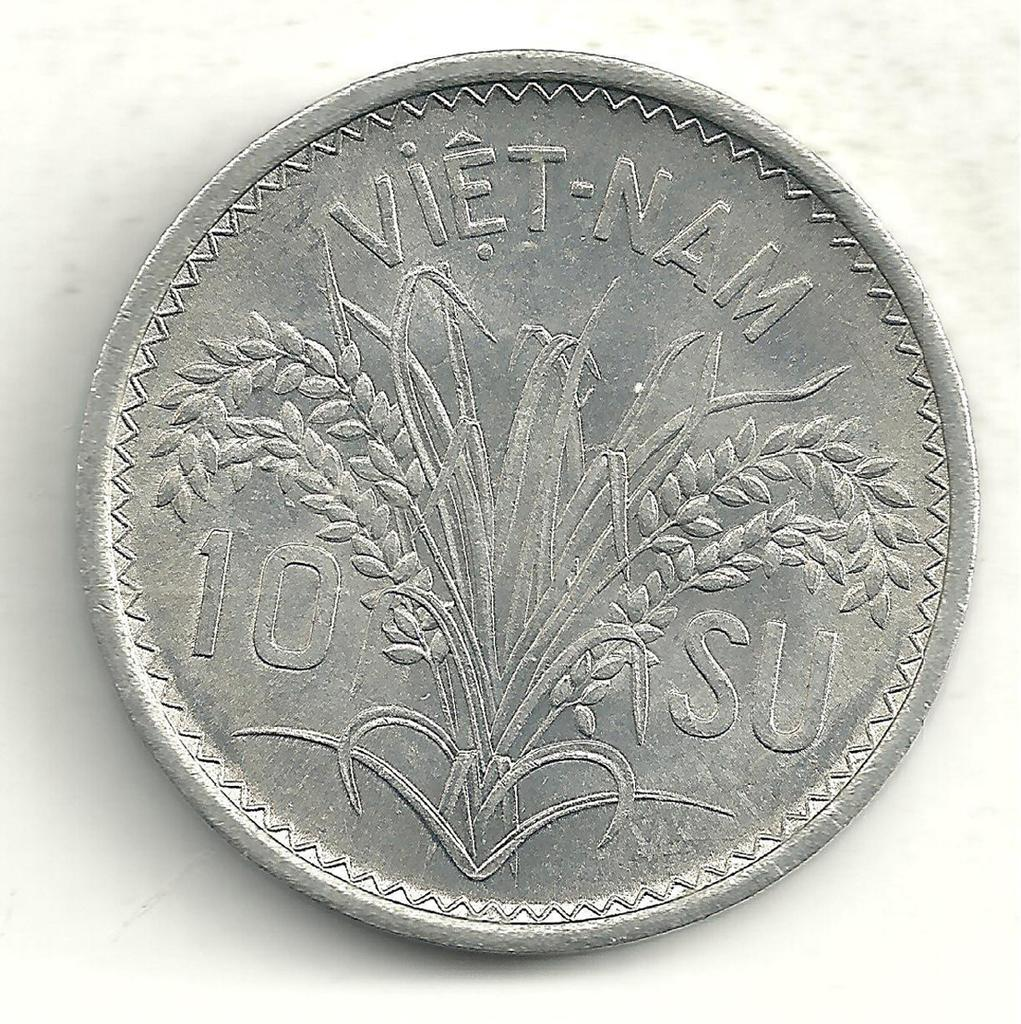<image>
Describe the image concisely. A silver coin that has the words "Viet-Nam" on it. 